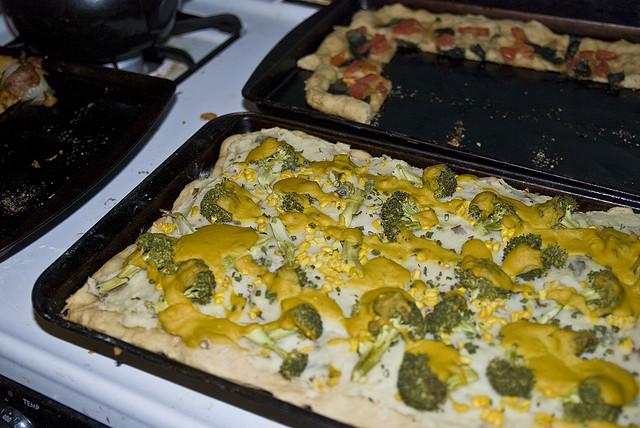Is this garlic bread?
Concise answer only. No. What are the green objects in the scene?
Give a very brief answer. Broccoli. How many pans are there?
Concise answer only. 3. 